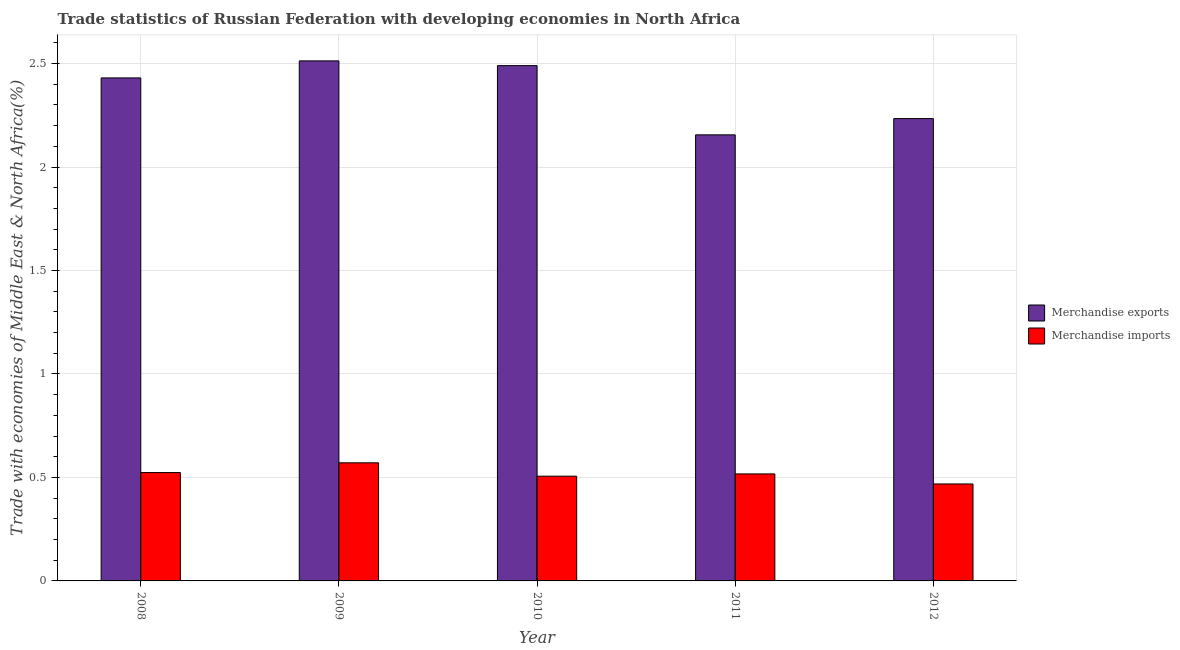How many different coloured bars are there?
Ensure brevity in your answer.  2. Are the number of bars per tick equal to the number of legend labels?
Keep it short and to the point. Yes. How many bars are there on the 1st tick from the right?
Your response must be concise. 2. In how many cases, is the number of bars for a given year not equal to the number of legend labels?
Provide a succinct answer. 0. What is the merchandise imports in 2012?
Offer a very short reply. 0.47. Across all years, what is the maximum merchandise imports?
Provide a short and direct response. 0.57. Across all years, what is the minimum merchandise exports?
Offer a terse response. 2.16. In which year was the merchandise imports maximum?
Make the answer very short. 2009. What is the total merchandise imports in the graph?
Your answer should be very brief. 2.59. What is the difference between the merchandise imports in 2008 and that in 2011?
Give a very brief answer. 0.01. What is the difference between the merchandise exports in 2011 and the merchandise imports in 2008?
Ensure brevity in your answer.  -0.28. What is the average merchandise imports per year?
Make the answer very short. 0.52. In how many years, is the merchandise exports greater than 1 %?
Keep it short and to the point. 5. What is the ratio of the merchandise imports in 2009 to that in 2010?
Ensure brevity in your answer.  1.13. Is the merchandise imports in 2008 less than that in 2012?
Make the answer very short. No. Is the difference between the merchandise exports in 2009 and 2010 greater than the difference between the merchandise imports in 2009 and 2010?
Your answer should be very brief. No. What is the difference between the highest and the second highest merchandise imports?
Keep it short and to the point. 0.05. What is the difference between the highest and the lowest merchandise exports?
Give a very brief answer. 0.36. In how many years, is the merchandise exports greater than the average merchandise exports taken over all years?
Your answer should be compact. 3. What does the 1st bar from the left in 2008 represents?
Give a very brief answer. Merchandise exports. What does the 2nd bar from the right in 2009 represents?
Offer a very short reply. Merchandise exports. How many bars are there?
Make the answer very short. 10. Are all the bars in the graph horizontal?
Your answer should be very brief. No. How many years are there in the graph?
Give a very brief answer. 5. What is the difference between two consecutive major ticks on the Y-axis?
Provide a short and direct response. 0.5. Does the graph contain grids?
Your response must be concise. Yes. Where does the legend appear in the graph?
Offer a terse response. Center right. How many legend labels are there?
Your answer should be very brief. 2. What is the title of the graph?
Keep it short and to the point. Trade statistics of Russian Federation with developing economies in North Africa. What is the label or title of the Y-axis?
Provide a short and direct response. Trade with economies of Middle East & North Africa(%). What is the Trade with economies of Middle East & North Africa(%) of Merchandise exports in 2008?
Your answer should be very brief. 2.43. What is the Trade with economies of Middle East & North Africa(%) in Merchandise imports in 2008?
Make the answer very short. 0.52. What is the Trade with economies of Middle East & North Africa(%) in Merchandise exports in 2009?
Your answer should be compact. 2.51. What is the Trade with economies of Middle East & North Africa(%) in Merchandise imports in 2009?
Your answer should be compact. 0.57. What is the Trade with economies of Middle East & North Africa(%) of Merchandise exports in 2010?
Provide a succinct answer. 2.49. What is the Trade with economies of Middle East & North Africa(%) in Merchandise imports in 2010?
Your answer should be compact. 0.51. What is the Trade with economies of Middle East & North Africa(%) of Merchandise exports in 2011?
Offer a very short reply. 2.16. What is the Trade with economies of Middle East & North Africa(%) in Merchandise imports in 2011?
Give a very brief answer. 0.52. What is the Trade with economies of Middle East & North Africa(%) of Merchandise exports in 2012?
Your answer should be compact. 2.23. What is the Trade with economies of Middle East & North Africa(%) in Merchandise imports in 2012?
Give a very brief answer. 0.47. Across all years, what is the maximum Trade with economies of Middle East & North Africa(%) of Merchandise exports?
Offer a very short reply. 2.51. Across all years, what is the maximum Trade with economies of Middle East & North Africa(%) in Merchandise imports?
Make the answer very short. 0.57. Across all years, what is the minimum Trade with economies of Middle East & North Africa(%) in Merchandise exports?
Your answer should be very brief. 2.16. Across all years, what is the minimum Trade with economies of Middle East & North Africa(%) in Merchandise imports?
Offer a very short reply. 0.47. What is the total Trade with economies of Middle East & North Africa(%) in Merchandise exports in the graph?
Make the answer very short. 11.82. What is the total Trade with economies of Middle East & North Africa(%) in Merchandise imports in the graph?
Your response must be concise. 2.59. What is the difference between the Trade with economies of Middle East & North Africa(%) of Merchandise exports in 2008 and that in 2009?
Provide a short and direct response. -0.08. What is the difference between the Trade with economies of Middle East & North Africa(%) in Merchandise imports in 2008 and that in 2009?
Your answer should be compact. -0.05. What is the difference between the Trade with economies of Middle East & North Africa(%) in Merchandise exports in 2008 and that in 2010?
Ensure brevity in your answer.  -0.06. What is the difference between the Trade with economies of Middle East & North Africa(%) of Merchandise imports in 2008 and that in 2010?
Your response must be concise. 0.02. What is the difference between the Trade with economies of Middle East & North Africa(%) in Merchandise exports in 2008 and that in 2011?
Your response must be concise. 0.28. What is the difference between the Trade with economies of Middle East & North Africa(%) in Merchandise imports in 2008 and that in 2011?
Provide a succinct answer. 0.01. What is the difference between the Trade with economies of Middle East & North Africa(%) in Merchandise exports in 2008 and that in 2012?
Offer a very short reply. 0.2. What is the difference between the Trade with economies of Middle East & North Africa(%) of Merchandise imports in 2008 and that in 2012?
Your answer should be very brief. 0.06. What is the difference between the Trade with economies of Middle East & North Africa(%) of Merchandise exports in 2009 and that in 2010?
Your answer should be compact. 0.02. What is the difference between the Trade with economies of Middle East & North Africa(%) of Merchandise imports in 2009 and that in 2010?
Your answer should be compact. 0.06. What is the difference between the Trade with economies of Middle East & North Africa(%) of Merchandise exports in 2009 and that in 2011?
Ensure brevity in your answer.  0.36. What is the difference between the Trade with economies of Middle East & North Africa(%) in Merchandise imports in 2009 and that in 2011?
Your answer should be compact. 0.05. What is the difference between the Trade with economies of Middle East & North Africa(%) of Merchandise exports in 2009 and that in 2012?
Ensure brevity in your answer.  0.28. What is the difference between the Trade with economies of Middle East & North Africa(%) in Merchandise imports in 2009 and that in 2012?
Keep it short and to the point. 0.1. What is the difference between the Trade with economies of Middle East & North Africa(%) in Merchandise exports in 2010 and that in 2011?
Keep it short and to the point. 0.33. What is the difference between the Trade with economies of Middle East & North Africa(%) of Merchandise imports in 2010 and that in 2011?
Give a very brief answer. -0.01. What is the difference between the Trade with economies of Middle East & North Africa(%) of Merchandise exports in 2010 and that in 2012?
Make the answer very short. 0.26. What is the difference between the Trade with economies of Middle East & North Africa(%) in Merchandise imports in 2010 and that in 2012?
Keep it short and to the point. 0.04. What is the difference between the Trade with economies of Middle East & North Africa(%) of Merchandise exports in 2011 and that in 2012?
Your answer should be compact. -0.08. What is the difference between the Trade with economies of Middle East & North Africa(%) in Merchandise imports in 2011 and that in 2012?
Ensure brevity in your answer.  0.05. What is the difference between the Trade with economies of Middle East & North Africa(%) in Merchandise exports in 2008 and the Trade with economies of Middle East & North Africa(%) in Merchandise imports in 2009?
Make the answer very short. 1.86. What is the difference between the Trade with economies of Middle East & North Africa(%) in Merchandise exports in 2008 and the Trade with economies of Middle East & North Africa(%) in Merchandise imports in 2010?
Your answer should be very brief. 1.92. What is the difference between the Trade with economies of Middle East & North Africa(%) of Merchandise exports in 2008 and the Trade with economies of Middle East & North Africa(%) of Merchandise imports in 2011?
Offer a terse response. 1.91. What is the difference between the Trade with economies of Middle East & North Africa(%) in Merchandise exports in 2008 and the Trade with economies of Middle East & North Africa(%) in Merchandise imports in 2012?
Make the answer very short. 1.96. What is the difference between the Trade with economies of Middle East & North Africa(%) in Merchandise exports in 2009 and the Trade with economies of Middle East & North Africa(%) in Merchandise imports in 2010?
Your response must be concise. 2.01. What is the difference between the Trade with economies of Middle East & North Africa(%) of Merchandise exports in 2009 and the Trade with economies of Middle East & North Africa(%) of Merchandise imports in 2011?
Provide a short and direct response. 2. What is the difference between the Trade with economies of Middle East & North Africa(%) of Merchandise exports in 2009 and the Trade with economies of Middle East & North Africa(%) of Merchandise imports in 2012?
Offer a very short reply. 2.04. What is the difference between the Trade with economies of Middle East & North Africa(%) of Merchandise exports in 2010 and the Trade with economies of Middle East & North Africa(%) of Merchandise imports in 2011?
Ensure brevity in your answer.  1.97. What is the difference between the Trade with economies of Middle East & North Africa(%) of Merchandise exports in 2010 and the Trade with economies of Middle East & North Africa(%) of Merchandise imports in 2012?
Offer a terse response. 2.02. What is the difference between the Trade with economies of Middle East & North Africa(%) of Merchandise exports in 2011 and the Trade with economies of Middle East & North Africa(%) of Merchandise imports in 2012?
Provide a short and direct response. 1.69. What is the average Trade with economies of Middle East & North Africa(%) of Merchandise exports per year?
Ensure brevity in your answer.  2.36. What is the average Trade with economies of Middle East & North Africa(%) in Merchandise imports per year?
Ensure brevity in your answer.  0.52. In the year 2008, what is the difference between the Trade with economies of Middle East & North Africa(%) in Merchandise exports and Trade with economies of Middle East & North Africa(%) in Merchandise imports?
Provide a succinct answer. 1.91. In the year 2009, what is the difference between the Trade with economies of Middle East & North Africa(%) of Merchandise exports and Trade with economies of Middle East & North Africa(%) of Merchandise imports?
Offer a terse response. 1.94. In the year 2010, what is the difference between the Trade with economies of Middle East & North Africa(%) in Merchandise exports and Trade with economies of Middle East & North Africa(%) in Merchandise imports?
Provide a succinct answer. 1.98. In the year 2011, what is the difference between the Trade with economies of Middle East & North Africa(%) of Merchandise exports and Trade with economies of Middle East & North Africa(%) of Merchandise imports?
Your answer should be compact. 1.64. In the year 2012, what is the difference between the Trade with economies of Middle East & North Africa(%) of Merchandise exports and Trade with economies of Middle East & North Africa(%) of Merchandise imports?
Provide a succinct answer. 1.77. What is the ratio of the Trade with economies of Middle East & North Africa(%) of Merchandise exports in 2008 to that in 2009?
Keep it short and to the point. 0.97. What is the ratio of the Trade with economies of Middle East & North Africa(%) of Merchandise imports in 2008 to that in 2009?
Give a very brief answer. 0.92. What is the ratio of the Trade with economies of Middle East & North Africa(%) in Merchandise exports in 2008 to that in 2010?
Provide a short and direct response. 0.98. What is the ratio of the Trade with economies of Middle East & North Africa(%) of Merchandise imports in 2008 to that in 2010?
Your answer should be compact. 1.03. What is the ratio of the Trade with economies of Middle East & North Africa(%) in Merchandise exports in 2008 to that in 2011?
Make the answer very short. 1.13. What is the ratio of the Trade with economies of Middle East & North Africa(%) of Merchandise imports in 2008 to that in 2011?
Ensure brevity in your answer.  1.01. What is the ratio of the Trade with economies of Middle East & North Africa(%) in Merchandise exports in 2008 to that in 2012?
Provide a short and direct response. 1.09. What is the ratio of the Trade with economies of Middle East & North Africa(%) of Merchandise imports in 2008 to that in 2012?
Offer a terse response. 1.12. What is the ratio of the Trade with economies of Middle East & North Africa(%) of Merchandise exports in 2009 to that in 2010?
Give a very brief answer. 1.01. What is the ratio of the Trade with economies of Middle East & North Africa(%) of Merchandise imports in 2009 to that in 2010?
Give a very brief answer. 1.13. What is the ratio of the Trade with economies of Middle East & North Africa(%) in Merchandise exports in 2009 to that in 2011?
Give a very brief answer. 1.17. What is the ratio of the Trade with economies of Middle East & North Africa(%) of Merchandise imports in 2009 to that in 2011?
Keep it short and to the point. 1.1. What is the ratio of the Trade with economies of Middle East & North Africa(%) in Merchandise exports in 2009 to that in 2012?
Your answer should be compact. 1.12. What is the ratio of the Trade with economies of Middle East & North Africa(%) in Merchandise imports in 2009 to that in 2012?
Your answer should be compact. 1.22. What is the ratio of the Trade with economies of Middle East & North Africa(%) in Merchandise exports in 2010 to that in 2011?
Your response must be concise. 1.16. What is the ratio of the Trade with economies of Middle East & North Africa(%) in Merchandise imports in 2010 to that in 2011?
Give a very brief answer. 0.98. What is the ratio of the Trade with economies of Middle East & North Africa(%) in Merchandise exports in 2010 to that in 2012?
Ensure brevity in your answer.  1.11. What is the ratio of the Trade with economies of Middle East & North Africa(%) of Merchandise imports in 2010 to that in 2012?
Provide a succinct answer. 1.08. What is the ratio of the Trade with economies of Middle East & North Africa(%) of Merchandise exports in 2011 to that in 2012?
Give a very brief answer. 0.96. What is the ratio of the Trade with economies of Middle East & North Africa(%) of Merchandise imports in 2011 to that in 2012?
Ensure brevity in your answer.  1.1. What is the difference between the highest and the second highest Trade with economies of Middle East & North Africa(%) in Merchandise exports?
Keep it short and to the point. 0.02. What is the difference between the highest and the second highest Trade with economies of Middle East & North Africa(%) of Merchandise imports?
Your answer should be very brief. 0.05. What is the difference between the highest and the lowest Trade with economies of Middle East & North Africa(%) of Merchandise exports?
Provide a short and direct response. 0.36. What is the difference between the highest and the lowest Trade with economies of Middle East & North Africa(%) in Merchandise imports?
Your answer should be compact. 0.1. 